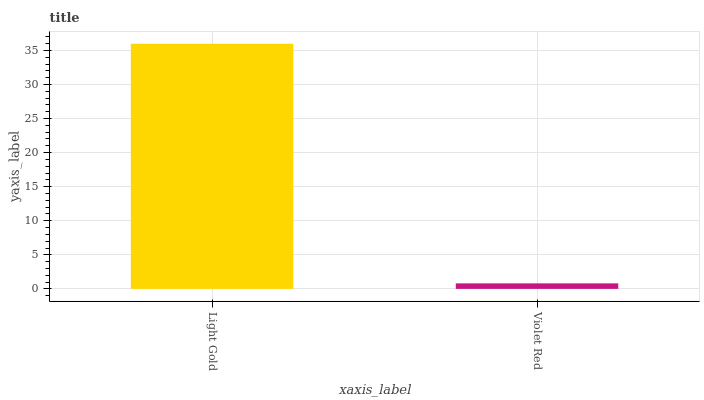Is Violet Red the minimum?
Answer yes or no. Yes. Is Light Gold the maximum?
Answer yes or no. Yes. Is Violet Red the maximum?
Answer yes or no. No. Is Light Gold greater than Violet Red?
Answer yes or no. Yes. Is Violet Red less than Light Gold?
Answer yes or no. Yes. Is Violet Red greater than Light Gold?
Answer yes or no. No. Is Light Gold less than Violet Red?
Answer yes or no. No. Is Light Gold the high median?
Answer yes or no. Yes. Is Violet Red the low median?
Answer yes or no. Yes. Is Violet Red the high median?
Answer yes or no. No. Is Light Gold the low median?
Answer yes or no. No. 